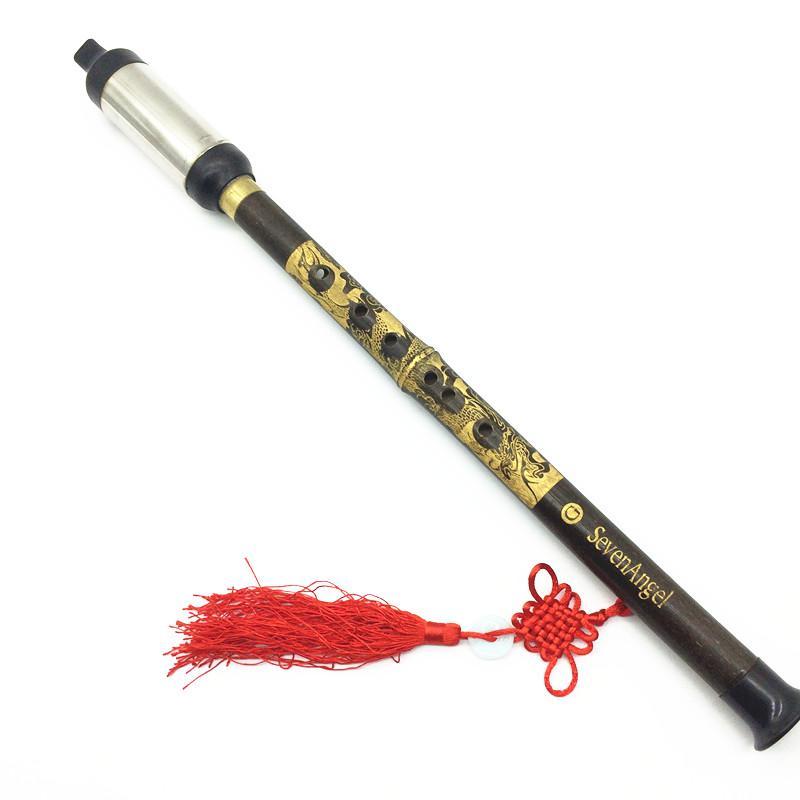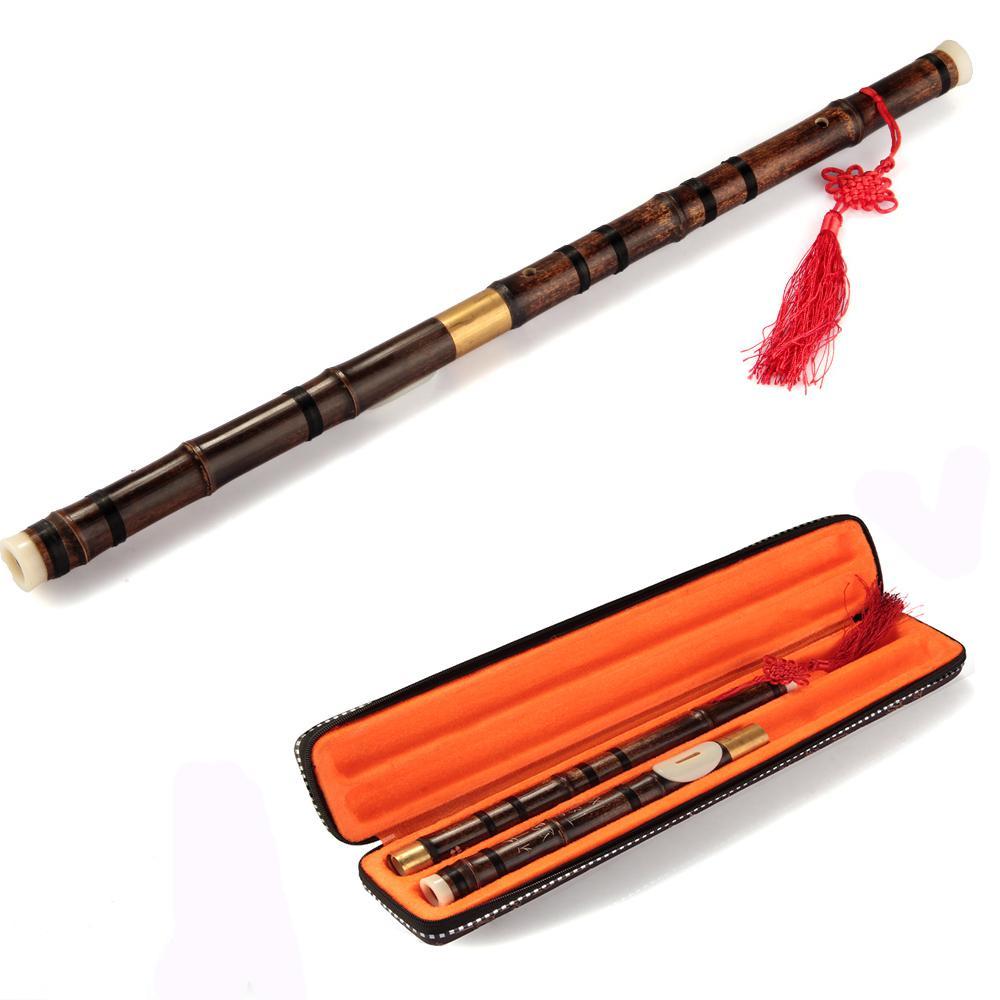The first image is the image on the left, the second image is the image on the right. For the images displayed, is the sentence "there is a flute with a red tassel hanging from the lower half and a soft fabric pouch next to it" factually correct? Answer yes or no. No. 